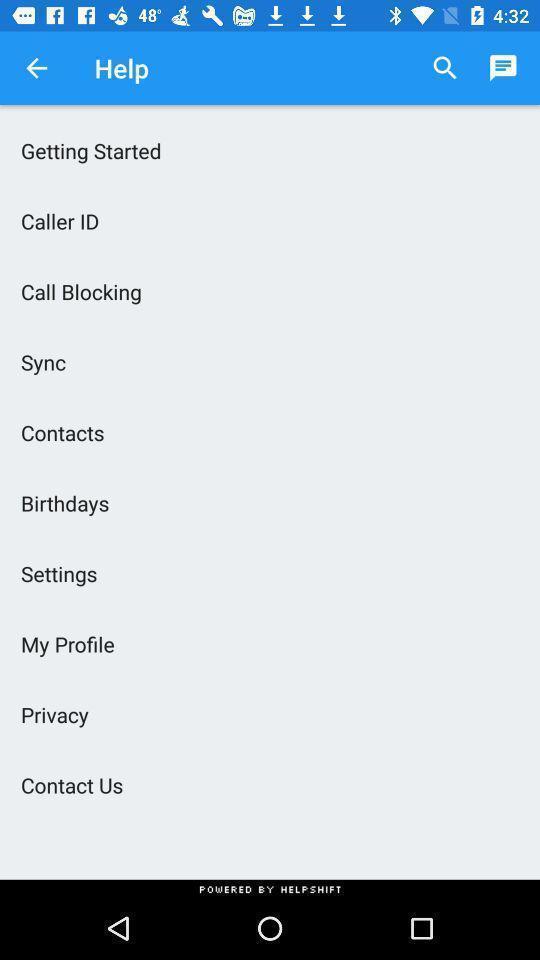Provide a textual representation of this image. Page displaying multiple options. 